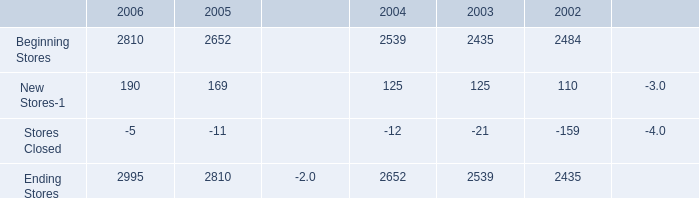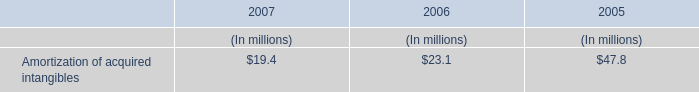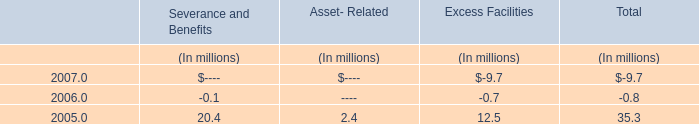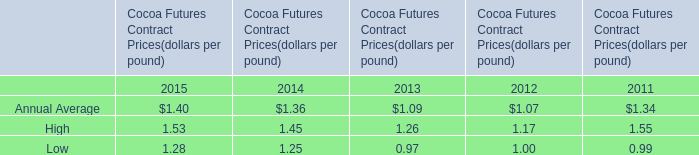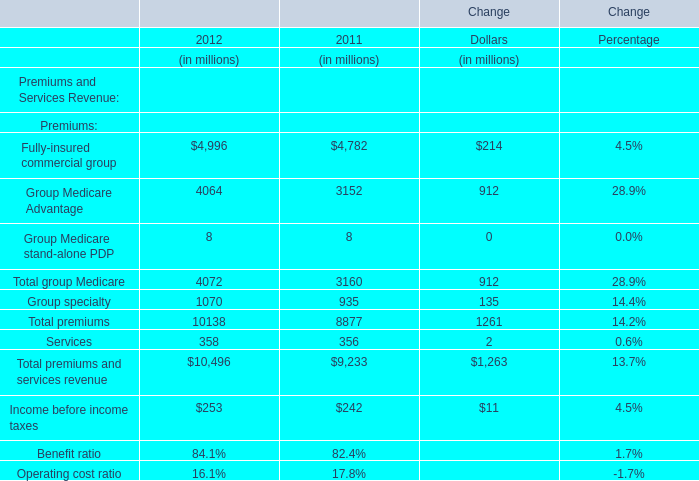What is the total value of Group Medicare Advantage,Group Medicare stand-alone PDP, Total group Medicare and Group specialty in 2011? (in million) 
Computations: (((3152 + 8) + 3160) + 935)
Answer: 7255.0. 